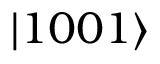<formula> <loc_0><loc_0><loc_500><loc_500>| 1 0 0 1 \rangle</formula> 